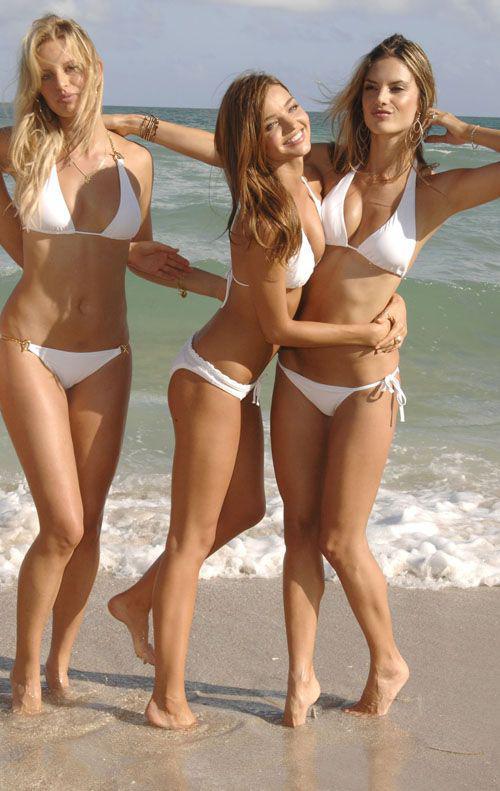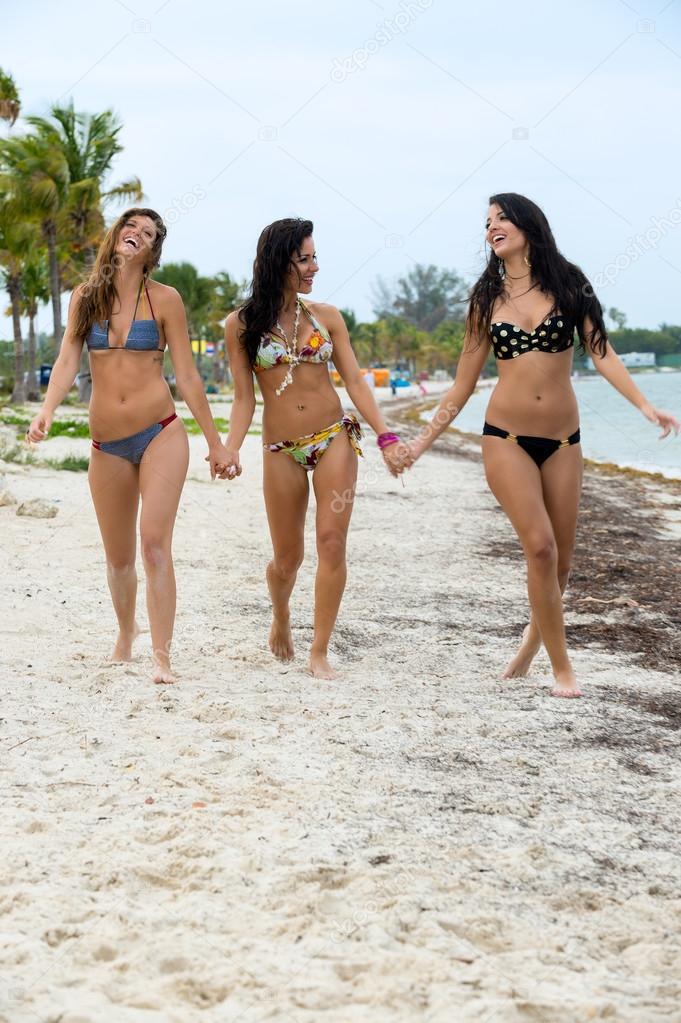The first image is the image on the left, the second image is the image on the right. Analyze the images presented: Is the assertion "The three women in bikinis in the image on the right are shown from behind." valid? Answer yes or no. No. The first image is the image on the left, the second image is the image on the right. Evaluate the accuracy of this statement regarding the images: "An image shows three bikini models with their rears to the camera, standing with arms around each other.". Is it true? Answer yes or no. No. 